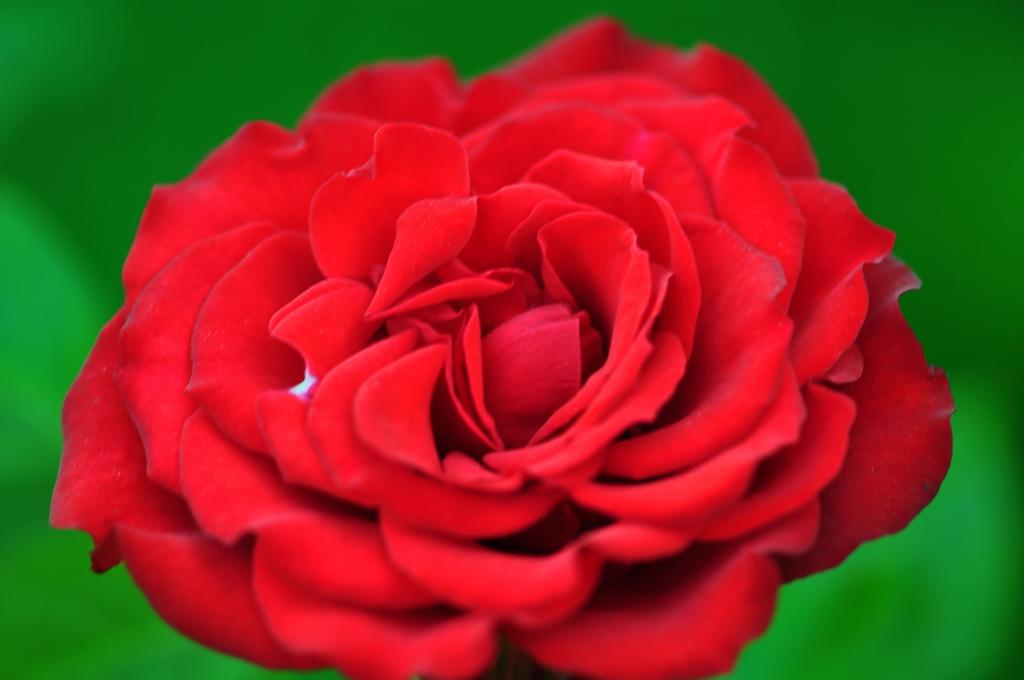What type of flower is in the image? There is a rose flower in the image. What sound does the chicken make in the image? There is no chicken present in the image, so it is not possible to determine the sound it might make. 